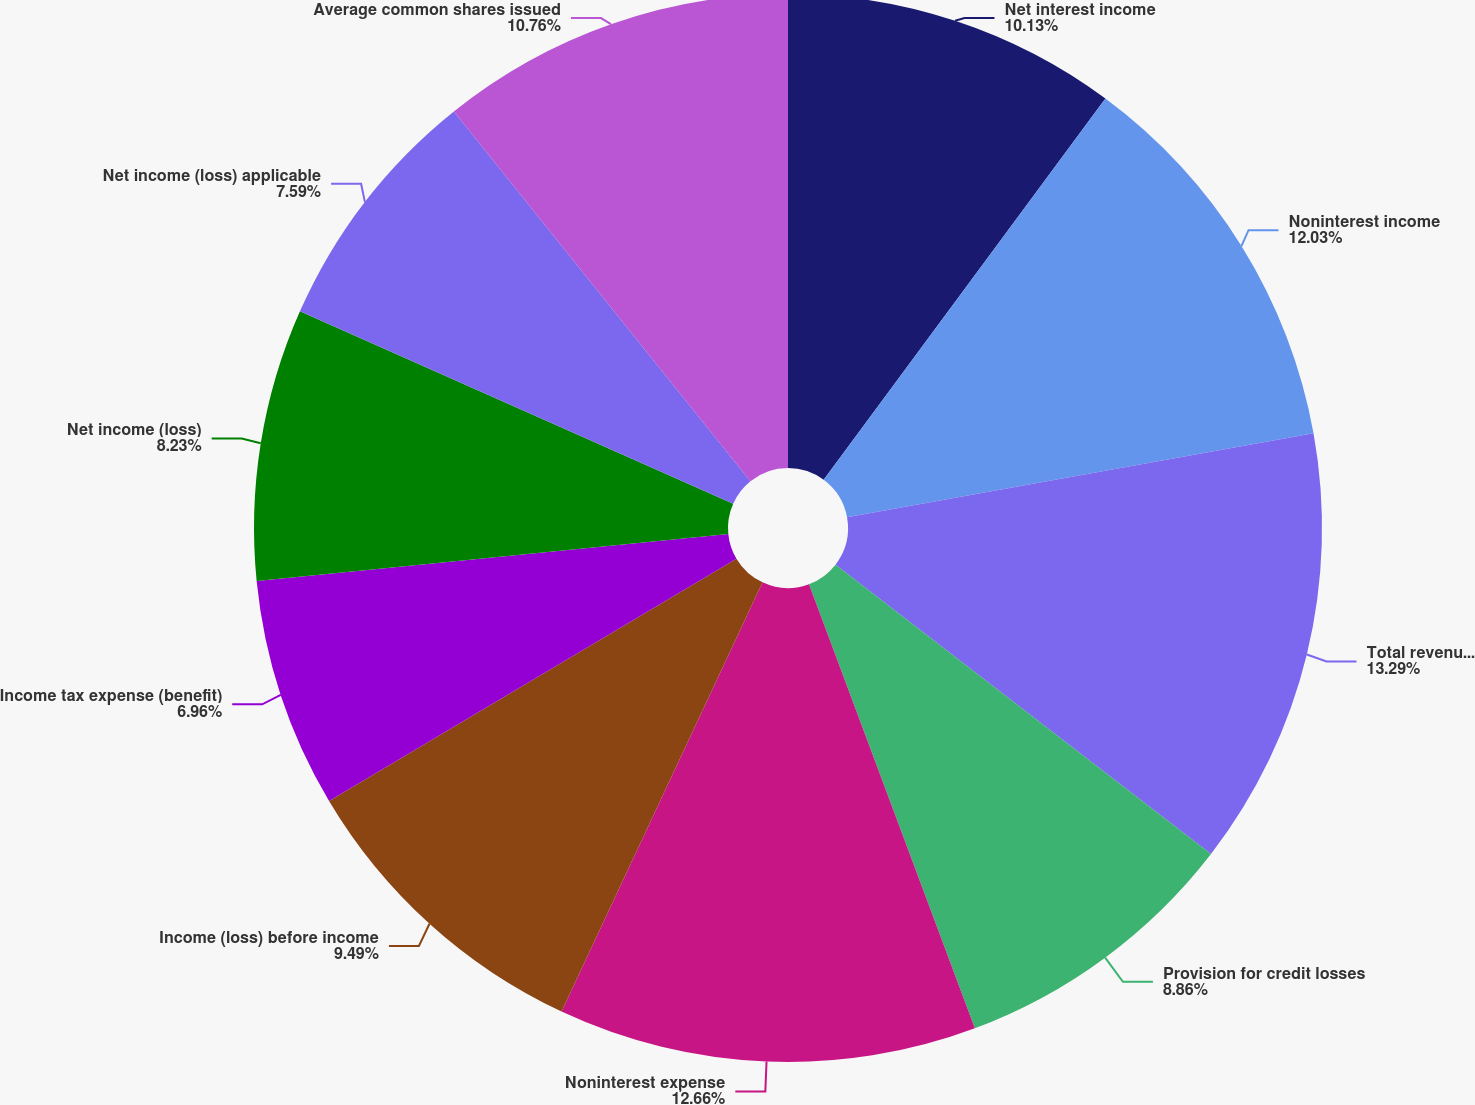Convert chart to OTSL. <chart><loc_0><loc_0><loc_500><loc_500><pie_chart><fcel>Net interest income<fcel>Noninterest income<fcel>Total revenue net of interest<fcel>Provision for credit losses<fcel>Noninterest expense<fcel>Income (loss) before income<fcel>Income tax expense (benefit)<fcel>Net income (loss)<fcel>Net income (loss) applicable<fcel>Average common shares issued<nl><fcel>10.13%<fcel>12.03%<fcel>13.29%<fcel>8.86%<fcel>12.66%<fcel>9.49%<fcel>6.96%<fcel>8.23%<fcel>7.59%<fcel>10.76%<nl></chart> 